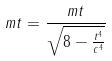Convert formula to latex. <formula><loc_0><loc_0><loc_500><loc_500>m t = \frac { m t } { \sqrt { 8 - \frac { t ^ { 4 } } { c ^ { 4 } } } }</formula> 